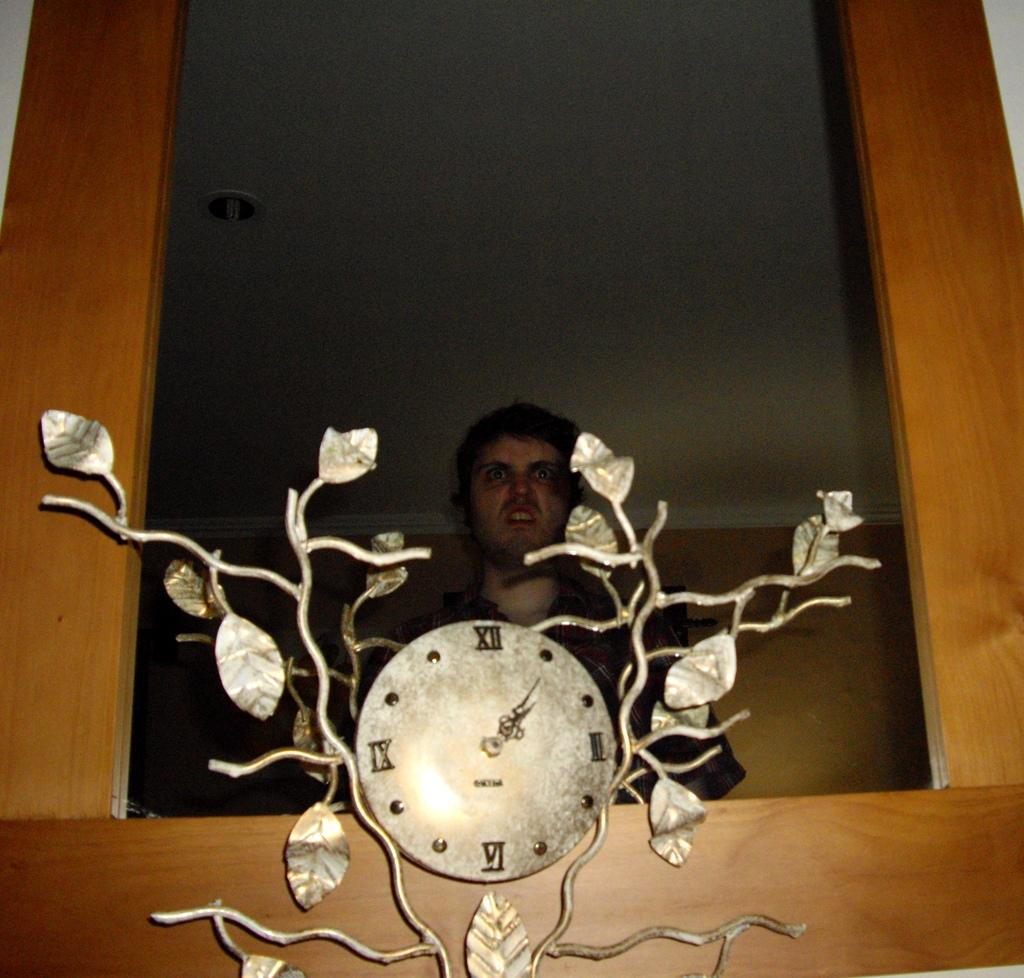<image>
Create a compact narrative representing the image presented. A man is posed behind a clock whose time is at 1:07. 